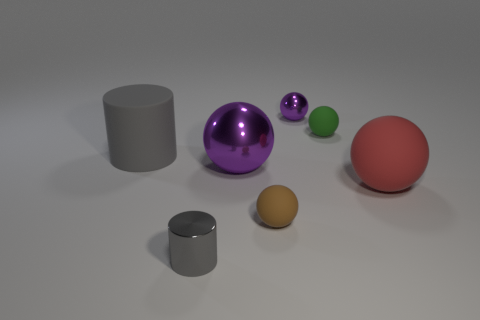Is there any other thing that is the same color as the large matte ball?
Provide a succinct answer. No. How many things are small metallic objects or big things behind the red thing?
Provide a succinct answer. 4. The tiny matte thing that is behind the large cylinder is what color?
Offer a terse response. Green. There is a matte object that is to the left of the big purple object; does it have the same size as the gray cylinder right of the large gray rubber thing?
Offer a terse response. No. Are there any gray cylinders of the same size as the red matte sphere?
Your answer should be very brief. Yes. How many tiny brown rubber objects are in front of the rubber ball behind the red rubber ball?
Your answer should be compact. 1. What is the material of the red object?
Ensure brevity in your answer.  Rubber. What number of big things are to the left of the gray shiny cylinder?
Your response must be concise. 1. Is the color of the large matte ball the same as the tiny metallic cylinder?
Your answer should be very brief. No. What number of large things have the same color as the metal cylinder?
Your answer should be very brief. 1. 